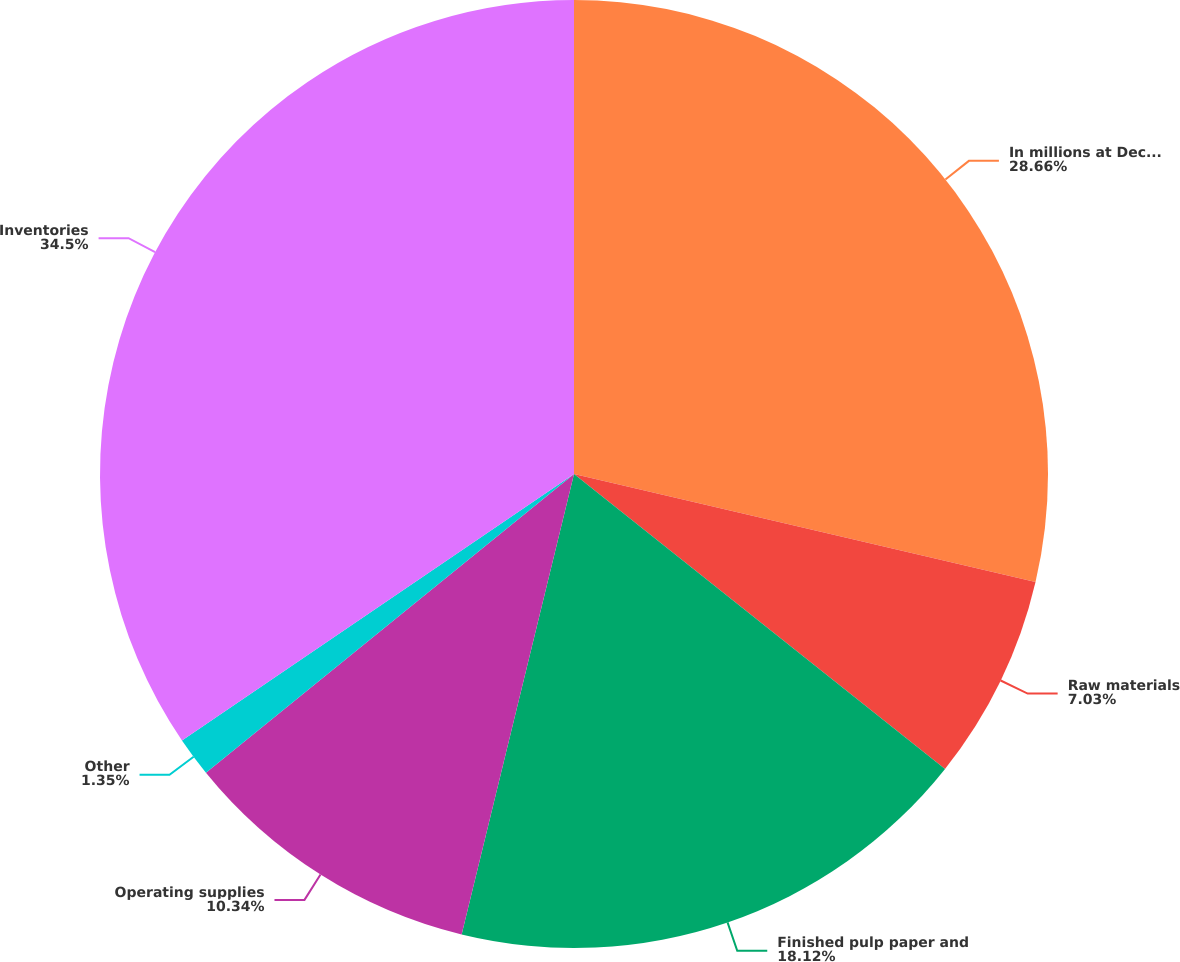<chart> <loc_0><loc_0><loc_500><loc_500><pie_chart><fcel>In millions at December 31<fcel>Raw materials<fcel>Finished pulp paper and<fcel>Operating supplies<fcel>Other<fcel>Inventories<nl><fcel>28.66%<fcel>7.03%<fcel>18.12%<fcel>10.34%<fcel>1.35%<fcel>34.5%<nl></chart> 